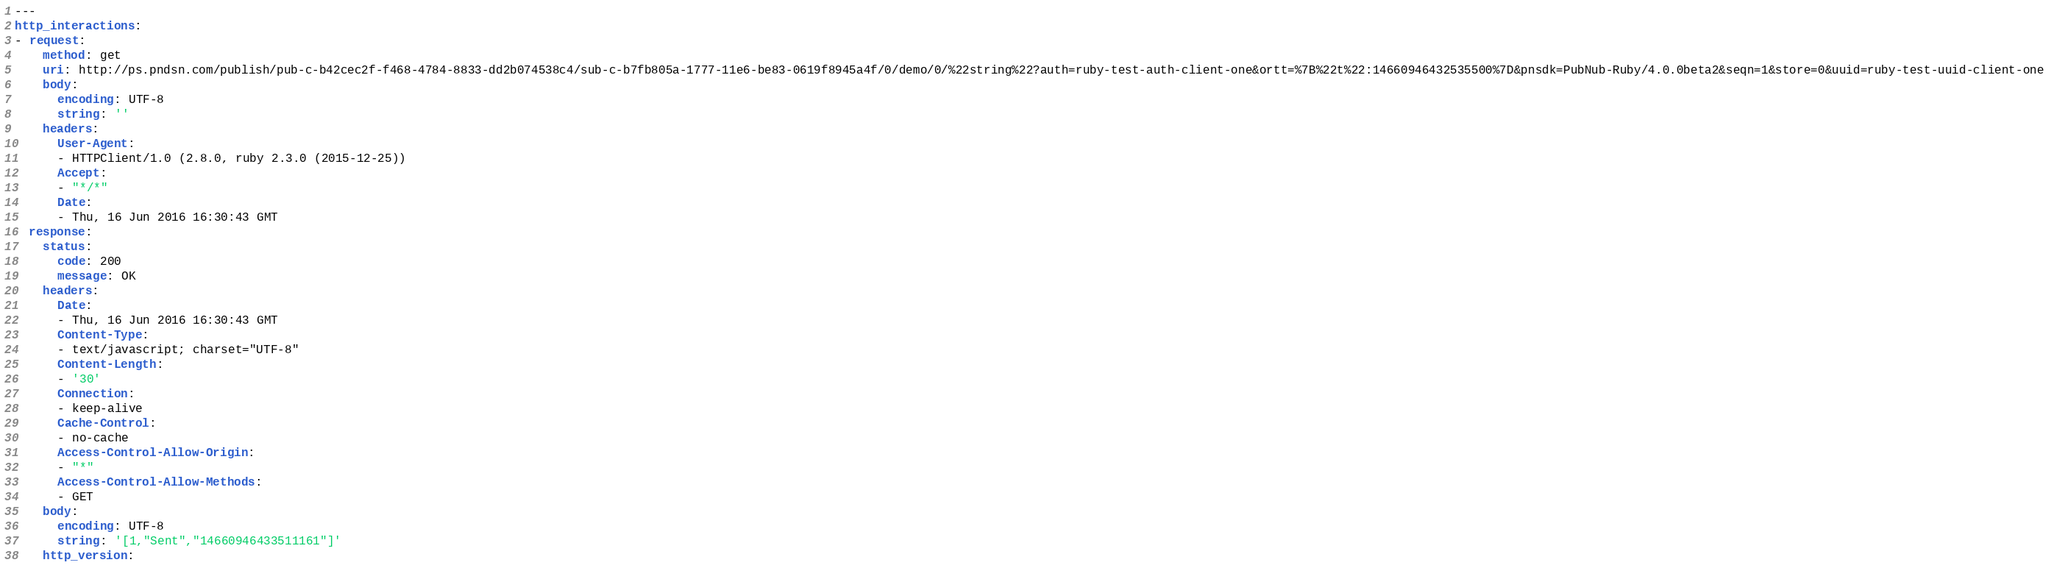Convert code to text. <code><loc_0><loc_0><loc_500><loc_500><_YAML_>---
http_interactions:
- request:
    method: get
    uri: http://ps.pndsn.com/publish/pub-c-b42cec2f-f468-4784-8833-dd2b074538c4/sub-c-b7fb805a-1777-11e6-be83-0619f8945a4f/0/demo/0/%22string%22?auth=ruby-test-auth-client-one&ortt=%7B%22t%22:14660946432535500%7D&pnsdk=PubNub-Ruby/4.0.0beta2&seqn=1&store=0&uuid=ruby-test-uuid-client-one
    body:
      encoding: UTF-8
      string: ''
    headers:
      User-Agent:
      - HTTPClient/1.0 (2.8.0, ruby 2.3.0 (2015-12-25))
      Accept:
      - "*/*"
      Date:
      - Thu, 16 Jun 2016 16:30:43 GMT
  response:
    status:
      code: 200
      message: OK
    headers:
      Date:
      - Thu, 16 Jun 2016 16:30:43 GMT
      Content-Type:
      - text/javascript; charset="UTF-8"
      Content-Length:
      - '30'
      Connection:
      - keep-alive
      Cache-Control:
      - no-cache
      Access-Control-Allow-Origin:
      - "*"
      Access-Control-Allow-Methods:
      - GET
    body:
      encoding: UTF-8
      string: '[1,"Sent","14660946433511161"]'
    http_version: </code> 